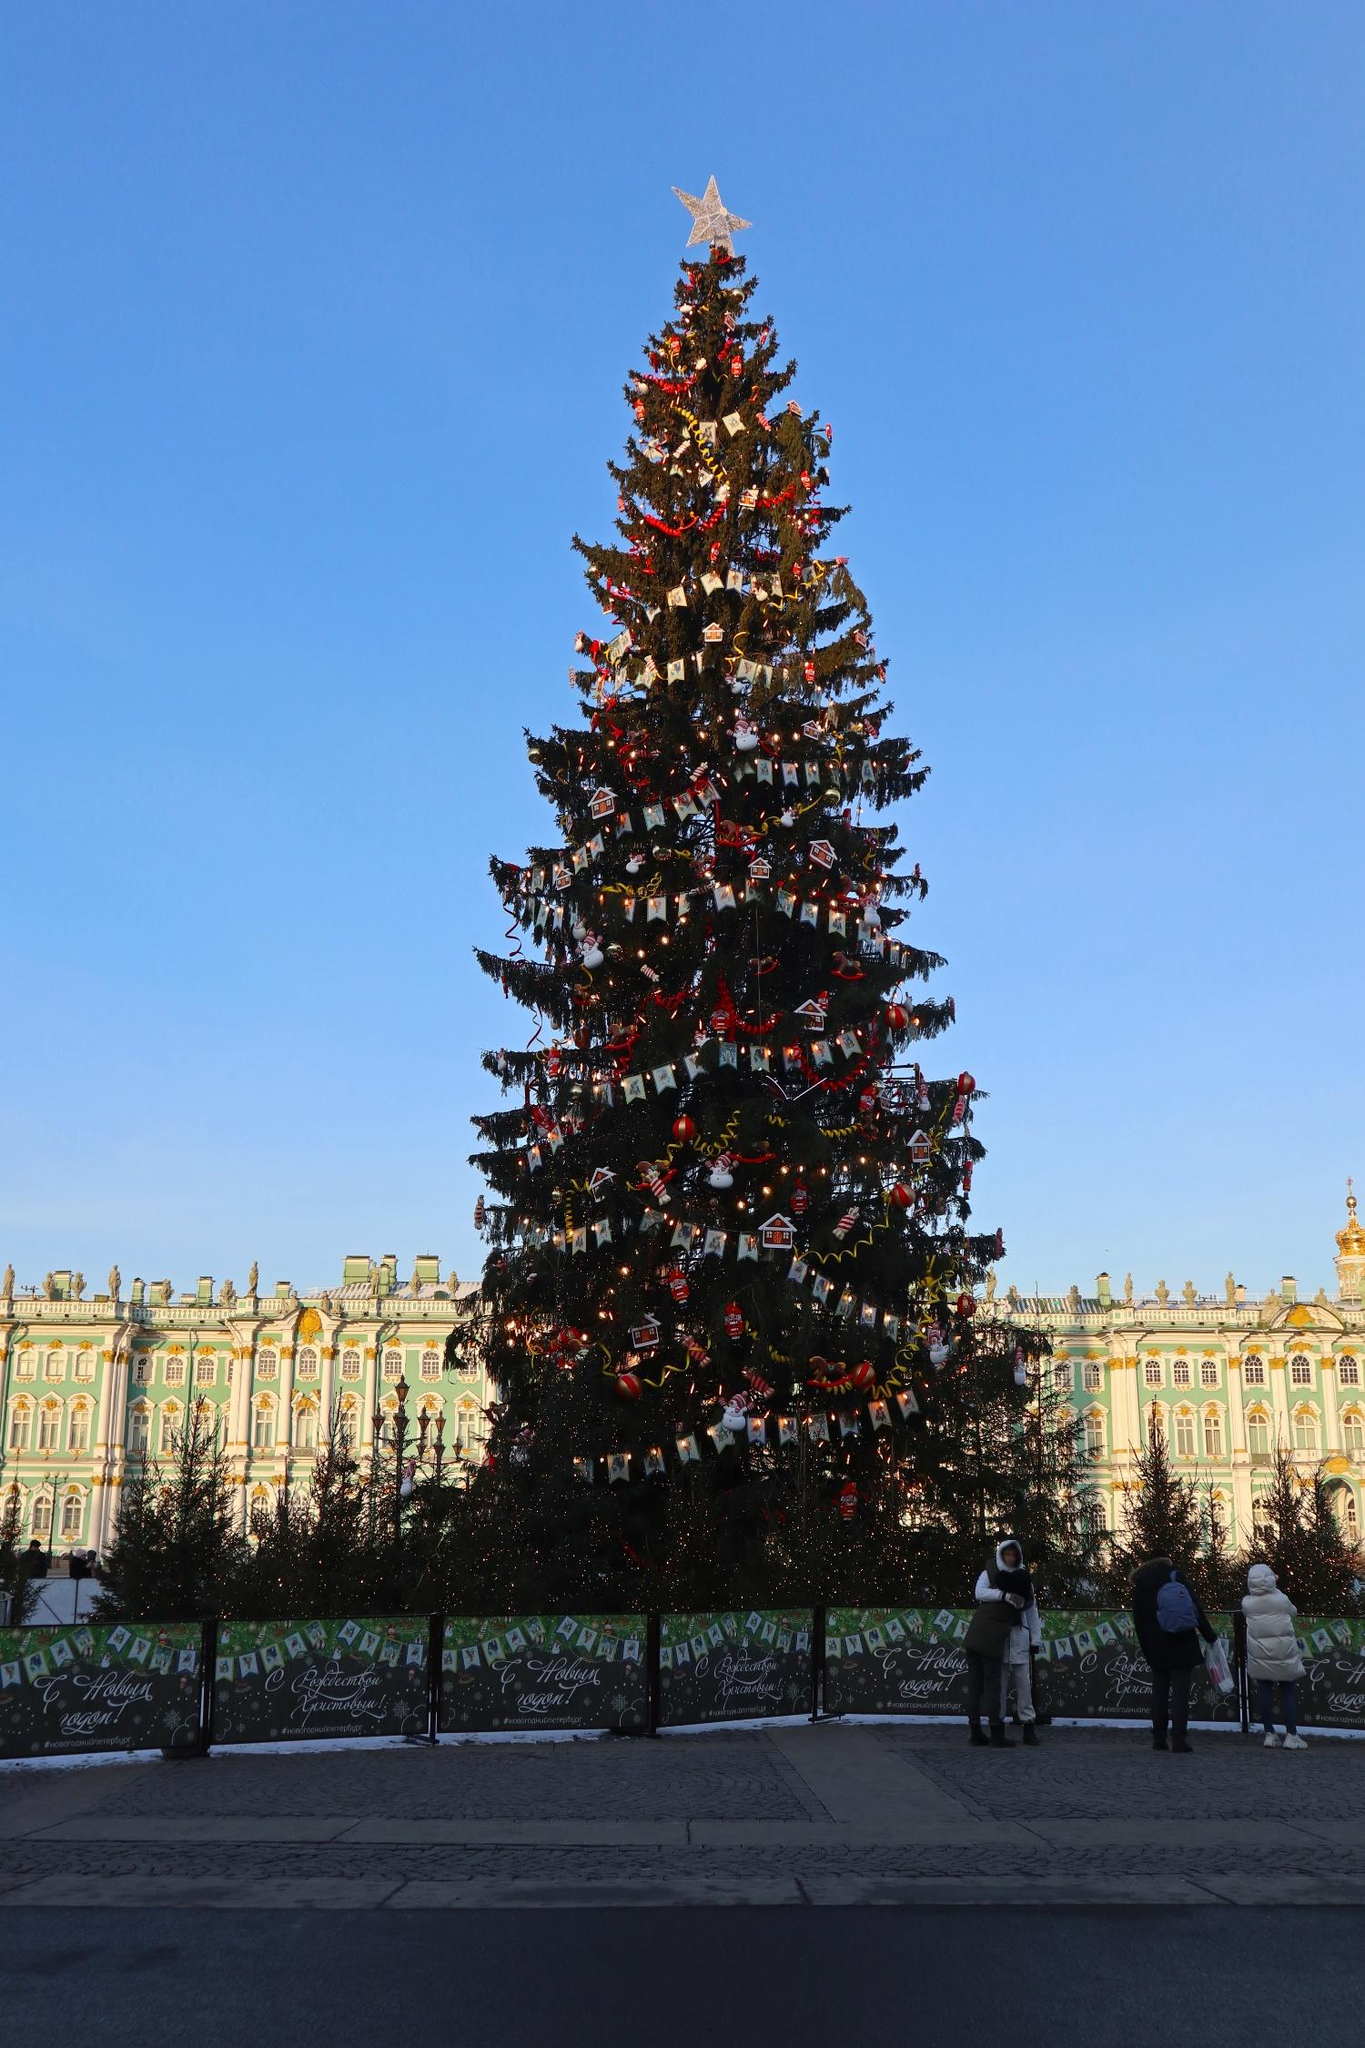What do you see happening in this image? The image depicts a grand Christmas tree standing prominently in front of an ornate building. The tree is beautifully adorned with red and gold ornaments, reaching towards the clear blue sky and topped with a large gold star. There are two individuals near the tree, one on the left and the other on the right, which provides a sense of scale. The building in the background is elaborate with an intricate design and a green roof, complementing the festive scene. This daytime setting exudes holiday cheer and tranquility, capturing the essence of the Christmas season. 